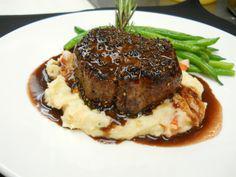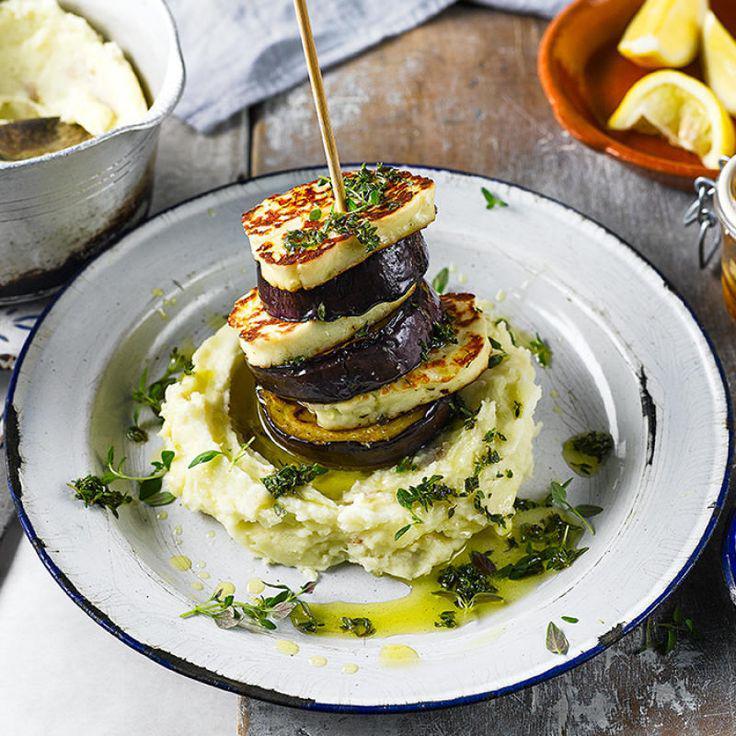The first image is the image on the left, the second image is the image on the right. Assess this claim about the two images: "One of the entrees is a stack of different layers.". Correct or not? Answer yes or no. Yes. The first image is the image on the left, the second image is the image on the right. Analyze the images presented: Is the assertion "One image shows a vertical stack of at least four 'solid' food items including similar items, and the other image shows a base food item with some other food item on top of it." valid? Answer yes or no. Yes. 